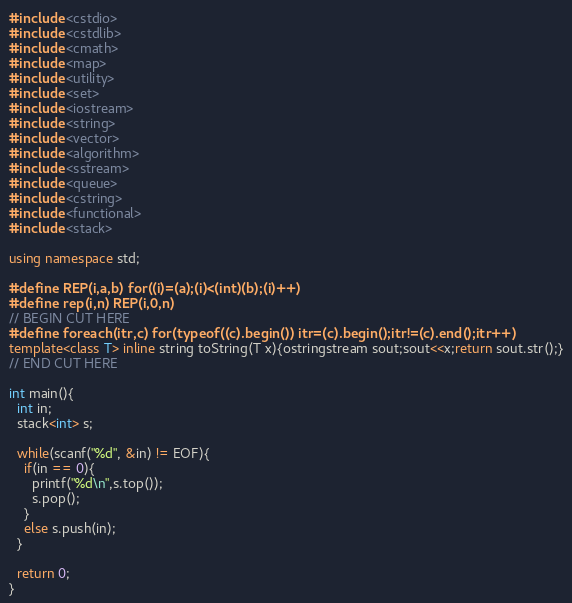<code> <loc_0><loc_0><loc_500><loc_500><_C++_>#include <cstdio>
#include <cstdlib>
#include <cmath>
#include <map>
#include <utility>
#include <set>
#include <iostream>
#include <string>
#include <vector>
#include <algorithm>
#include <sstream>
#include <queue>
#include <cstring>
#include <functional>
#include <stack>

using namespace std;

#define REP(i,a,b) for((i)=(a);(i)<(int)(b);(i)++)
#define rep(i,n) REP(i,0,n)
// BEGIN CUT HERE
#define foreach(itr,c) for(typeof((c).begin()) itr=(c).begin();itr!=(c).end();itr++)
template<class T> inline string toString(T x){ostringstream sout;sout<<x;return sout.str();}
// END CUT HERE

int main(){
  int in;
  stack<int> s;

  while(scanf("%d", &in) != EOF){
    if(in == 0){
      printf("%d\n",s.top());
      s.pop();
    }
    else s.push(in);
  }

  return 0;
}</code> 